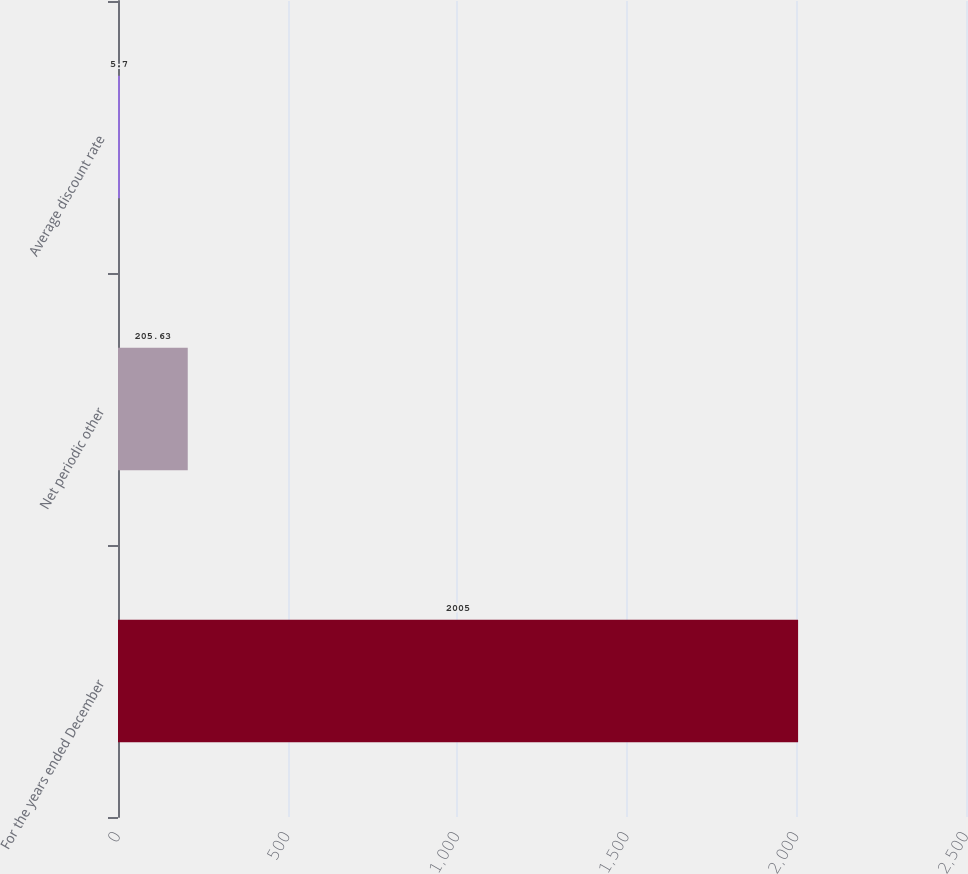<chart> <loc_0><loc_0><loc_500><loc_500><bar_chart><fcel>For the years ended December<fcel>Net periodic other<fcel>Average discount rate<nl><fcel>2005<fcel>205.63<fcel>5.7<nl></chart> 